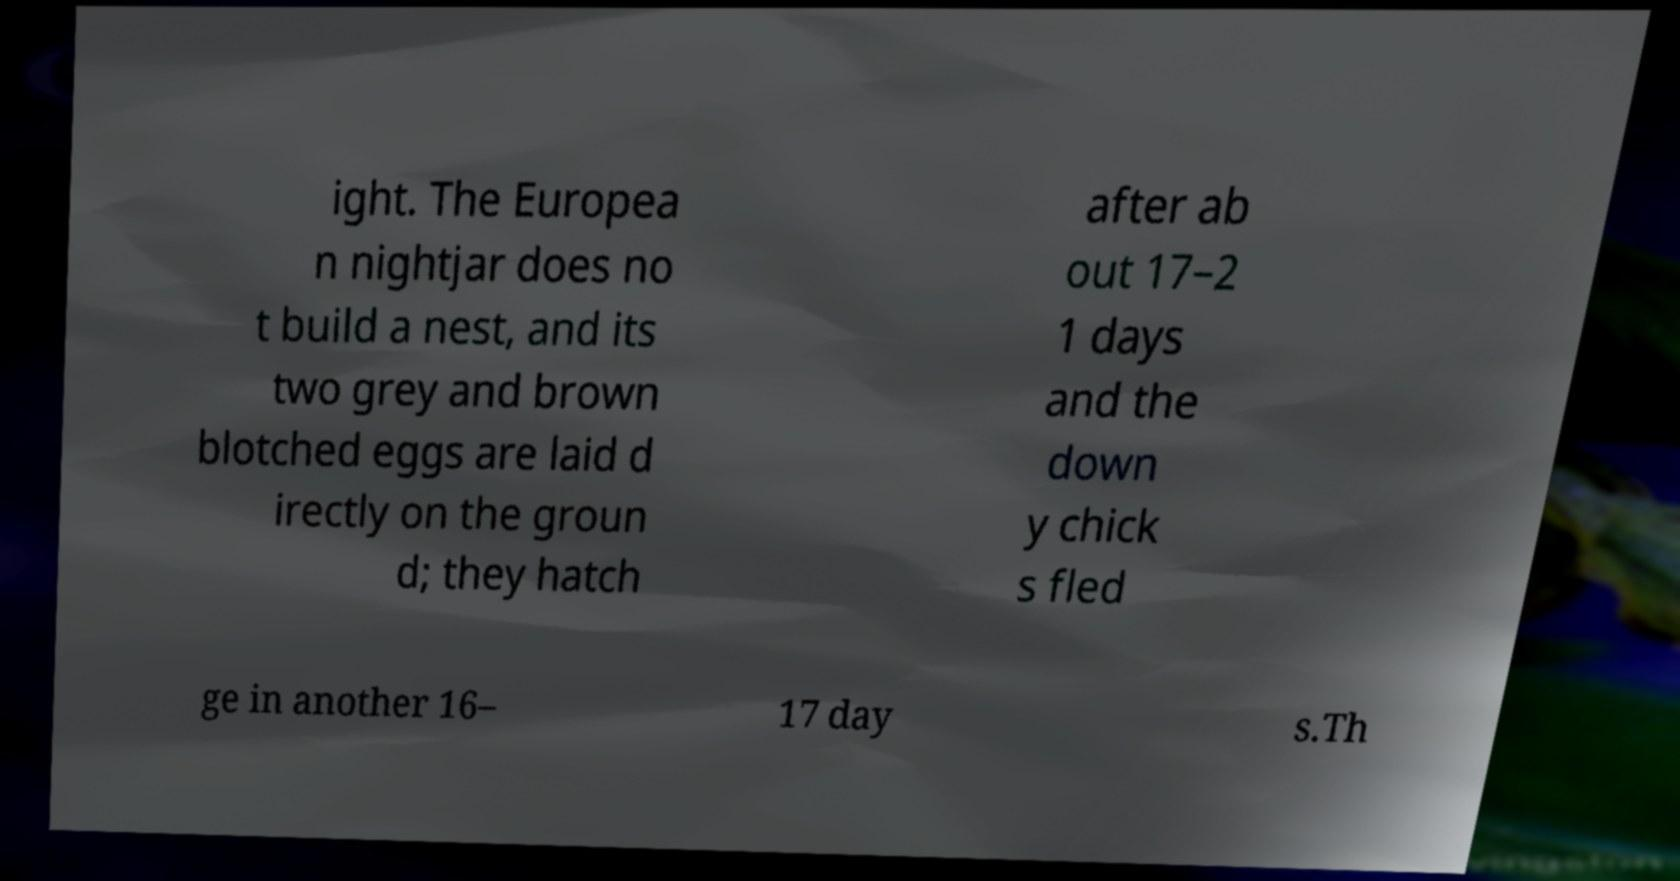Please identify and transcribe the text found in this image. ight. The Europea n nightjar does no t build a nest, and its two grey and brown blotched eggs are laid d irectly on the groun d; they hatch after ab out 17–2 1 days and the down y chick s fled ge in another 16– 17 day s.Th 